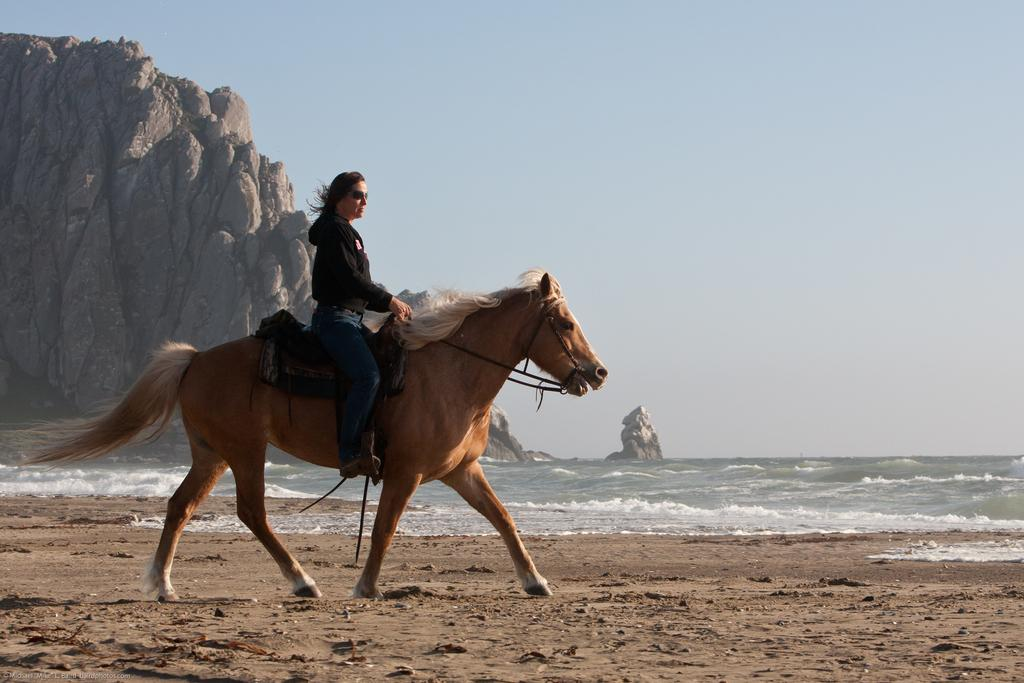Who is the main subject in the image? There is a woman in the image. What is the woman doing in the image? The woman is sitting on a horse. What can be seen in the background of the image? There is a mountain and water visible in the background of the image. How many goldfish are swimming in the water in the image? There are no goldfish visible in the image; only a mountain and water can be seen in the background. How many legs does the horse have in the image? The horse has four legs in the image, as horses typically have four legs. 